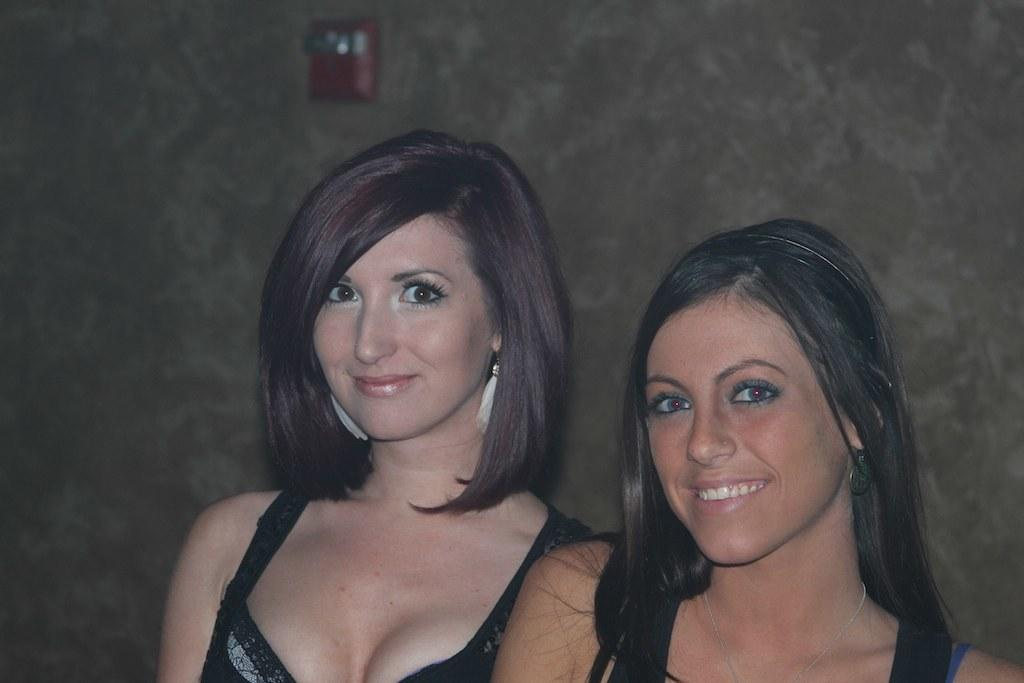How many people are present in the image? There are two ladies in the image. What can be seen in the background of the image? There is a wall in the background of the image. What type of robin can be seen perched on the wall in the image? There is no robin present in the image; it only features two ladies and a wall in the background. 